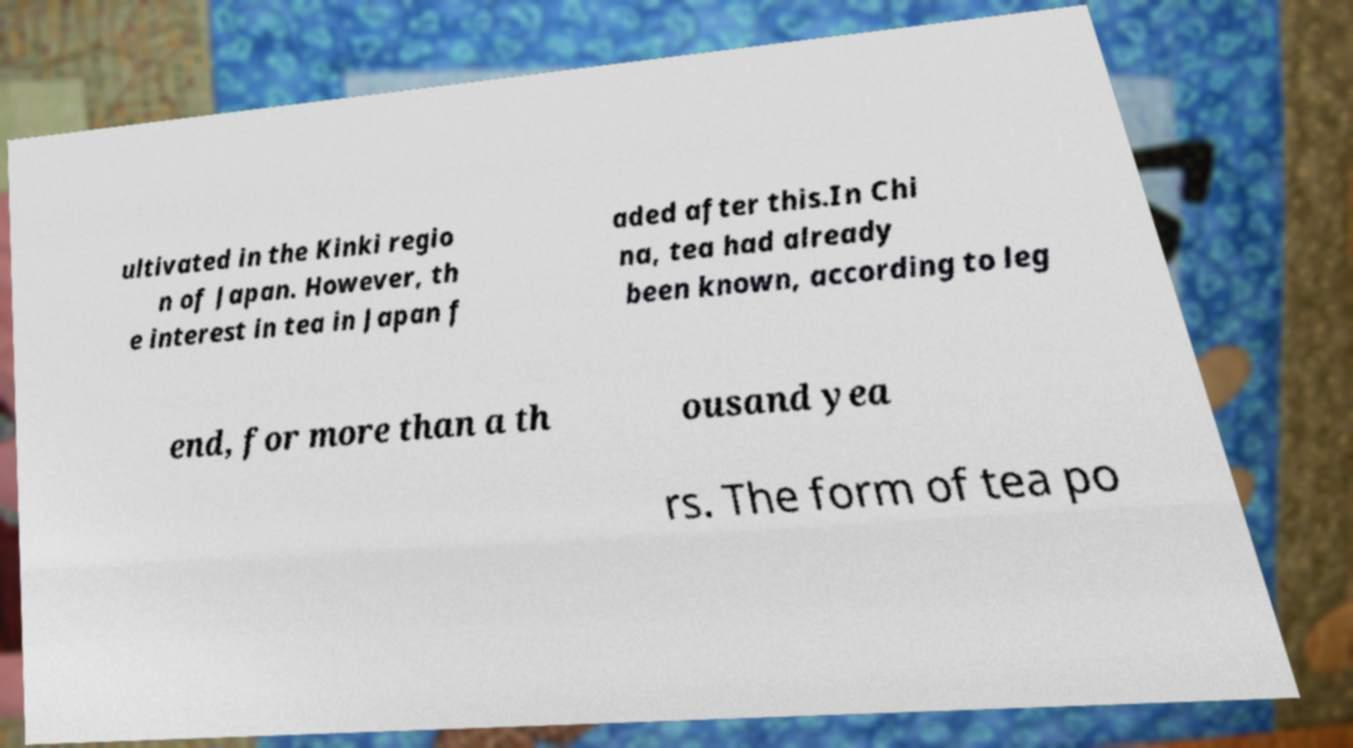Please identify and transcribe the text found in this image. ultivated in the Kinki regio n of Japan. However, th e interest in tea in Japan f aded after this.In Chi na, tea had already been known, according to leg end, for more than a th ousand yea rs. The form of tea po 